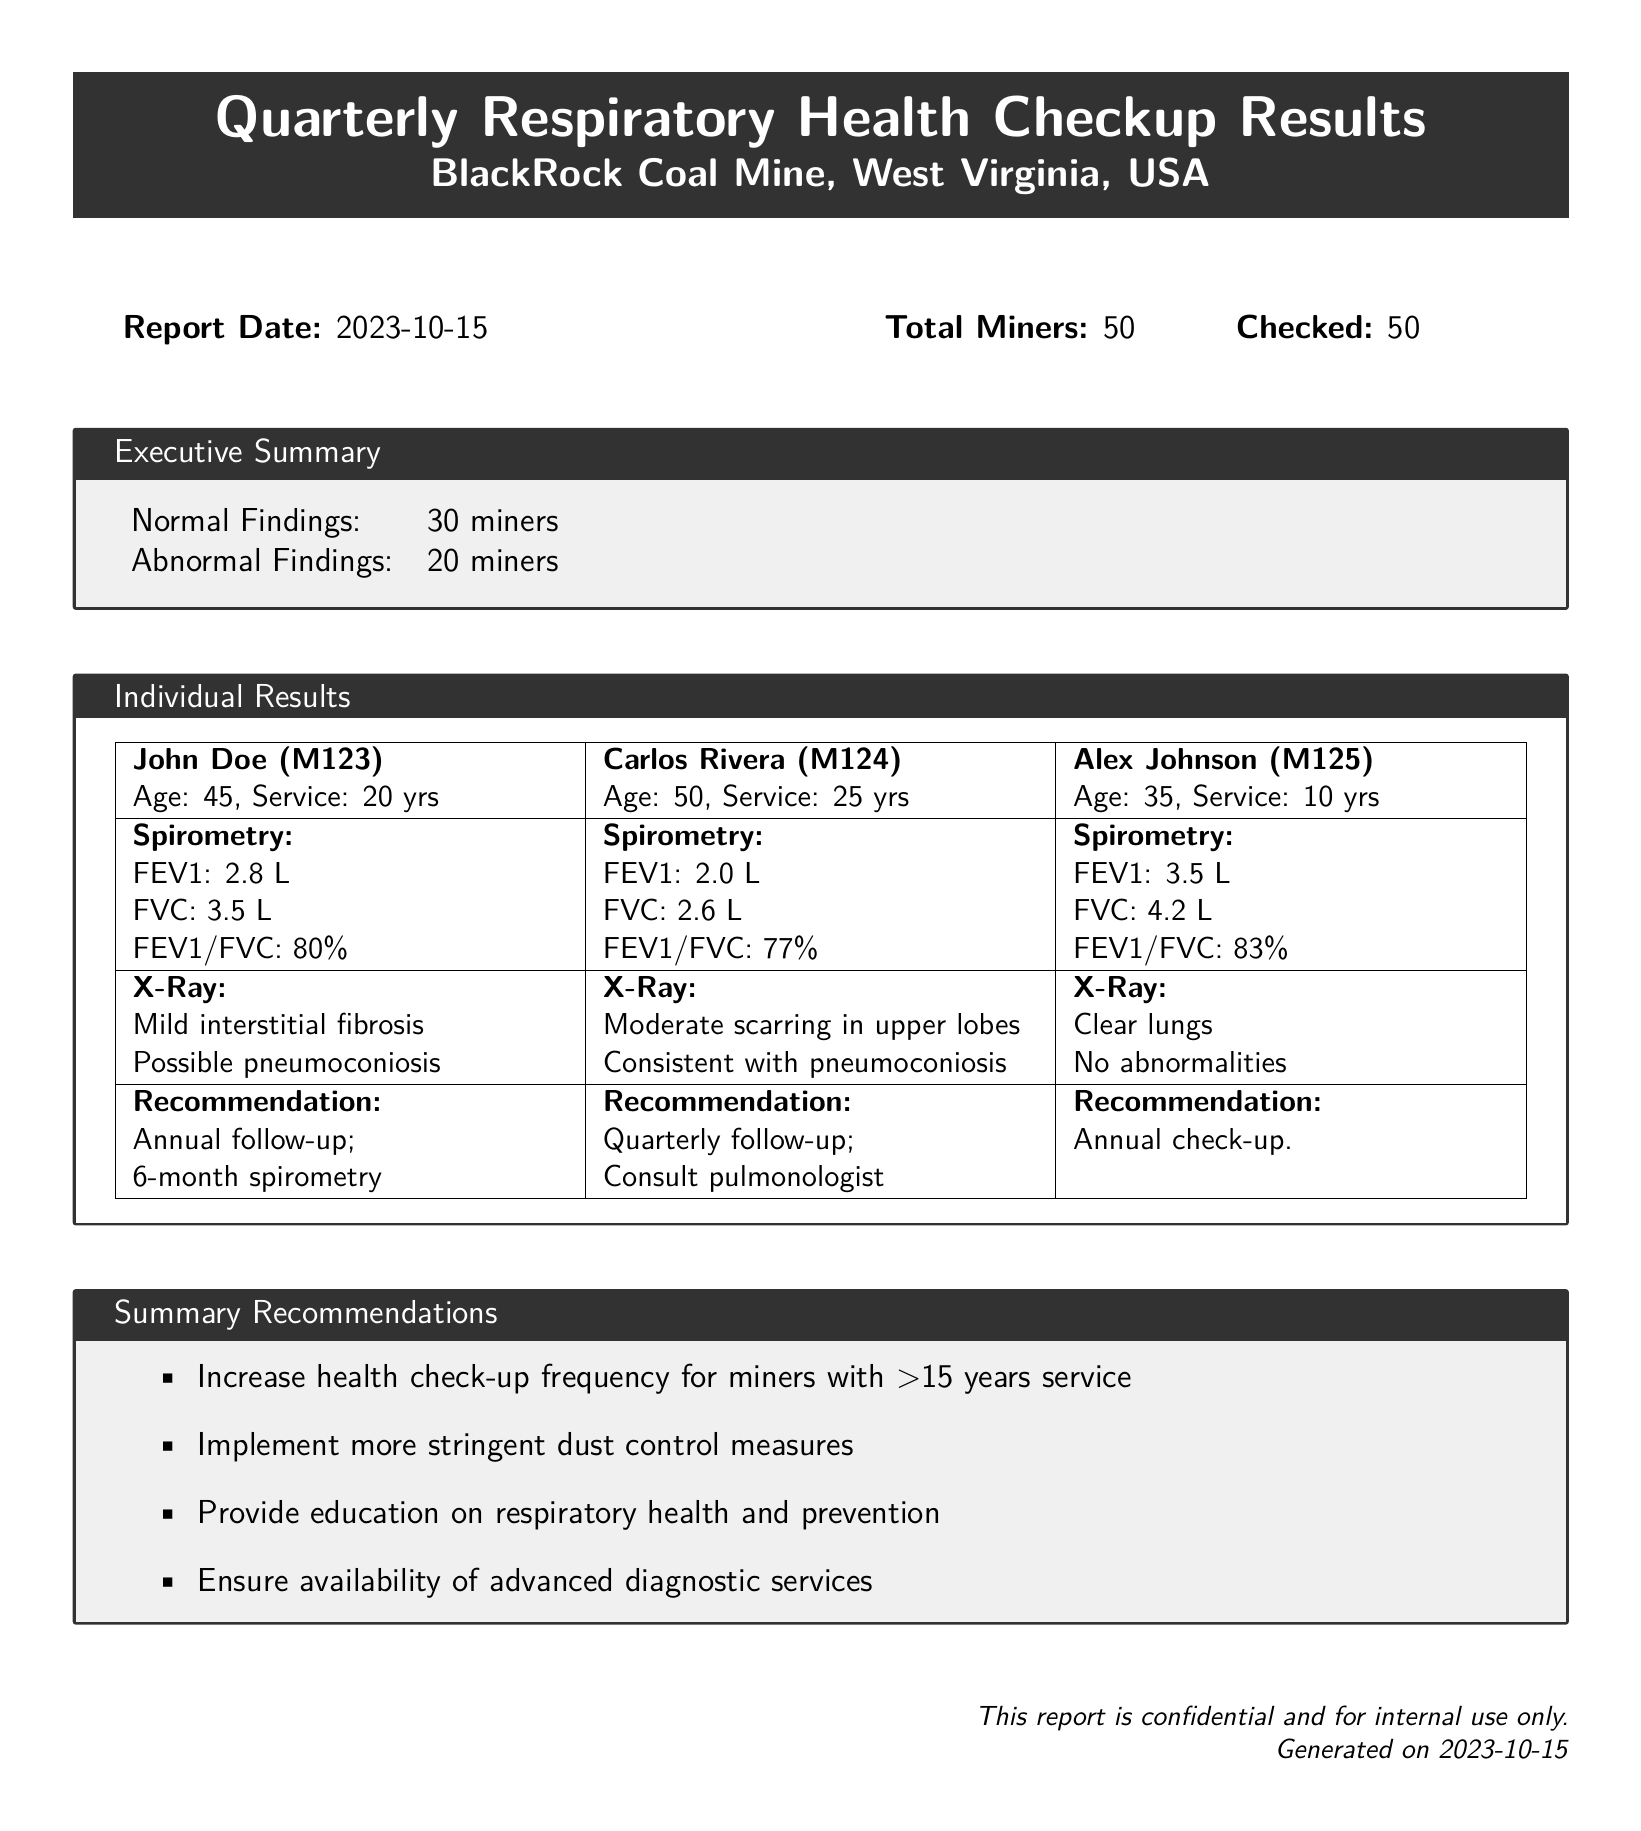What is the report date? The report date is specified near the top of the document, marking when the checkup results were generated.
Answer: 2023-10-15 How many miners were checked? The number of miners checked is indicated in the summary section of the document.
Answer: 50 What percentage of miners had abnormal findings? The executive summary provides the number of miners with abnormal findings, from which the percentage can be derived.
Answer: 40% What is the FEV1 value for John Doe? John Doe's spirometry results include his FEV1 value, as shown in the individual results table.
Answer: 2.8 L What is recommended for Carlos Rivera? The recommendation for Carlos Rivera is listed next to his individual results in the report.
Answer: Quarterly follow-up What lung condition is identified in John Doe's X-Ray? The X-Ray findings for John Doe include specific observations, which are detailed in the individual results section.
Answer: Mild interstitial fibrosis How many miners showed normal findings? The executive summary states the number of miners with normal findings at the end of the document.
Answer: 30 miners What is a suggested action for miners with more than 15 years of service? The summary recommendations section describes several actions based on miner service duration.
Answer: Increase health check-up frequency 